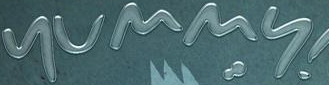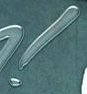Identify the words shown in these images in order, separated by a semicolon. yummy; ! 